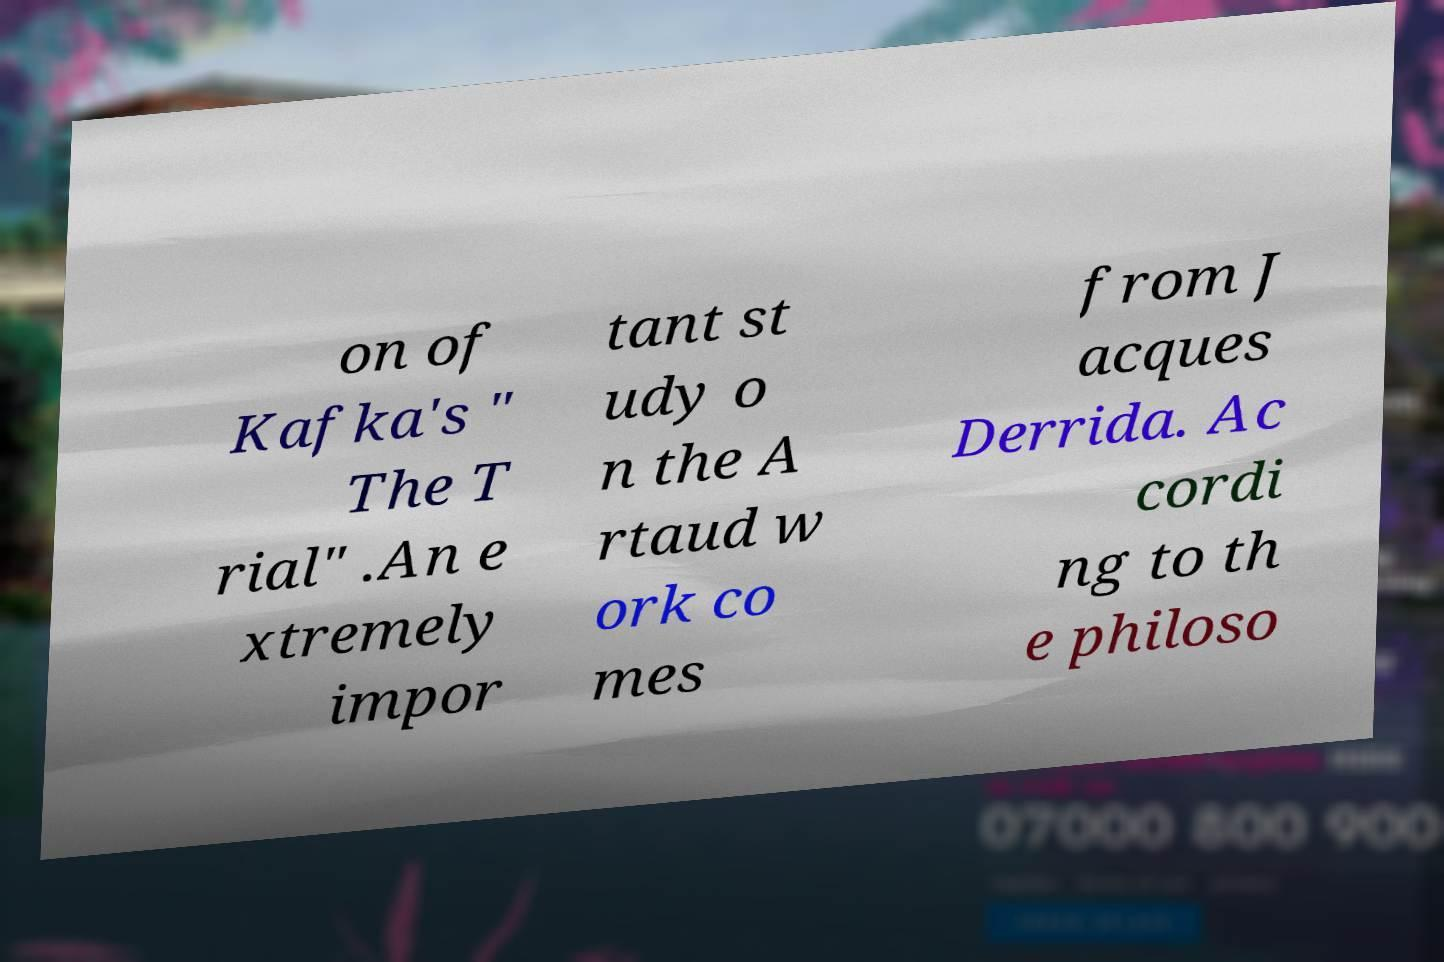There's text embedded in this image that I need extracted. Can you transcribe it verbatim? on of Kafka's " The T rial" .An e xtremely impor tant st udy o n the A rtaud w ork co mes from J acques Derrida. Ac cordi ng to th e philoso 